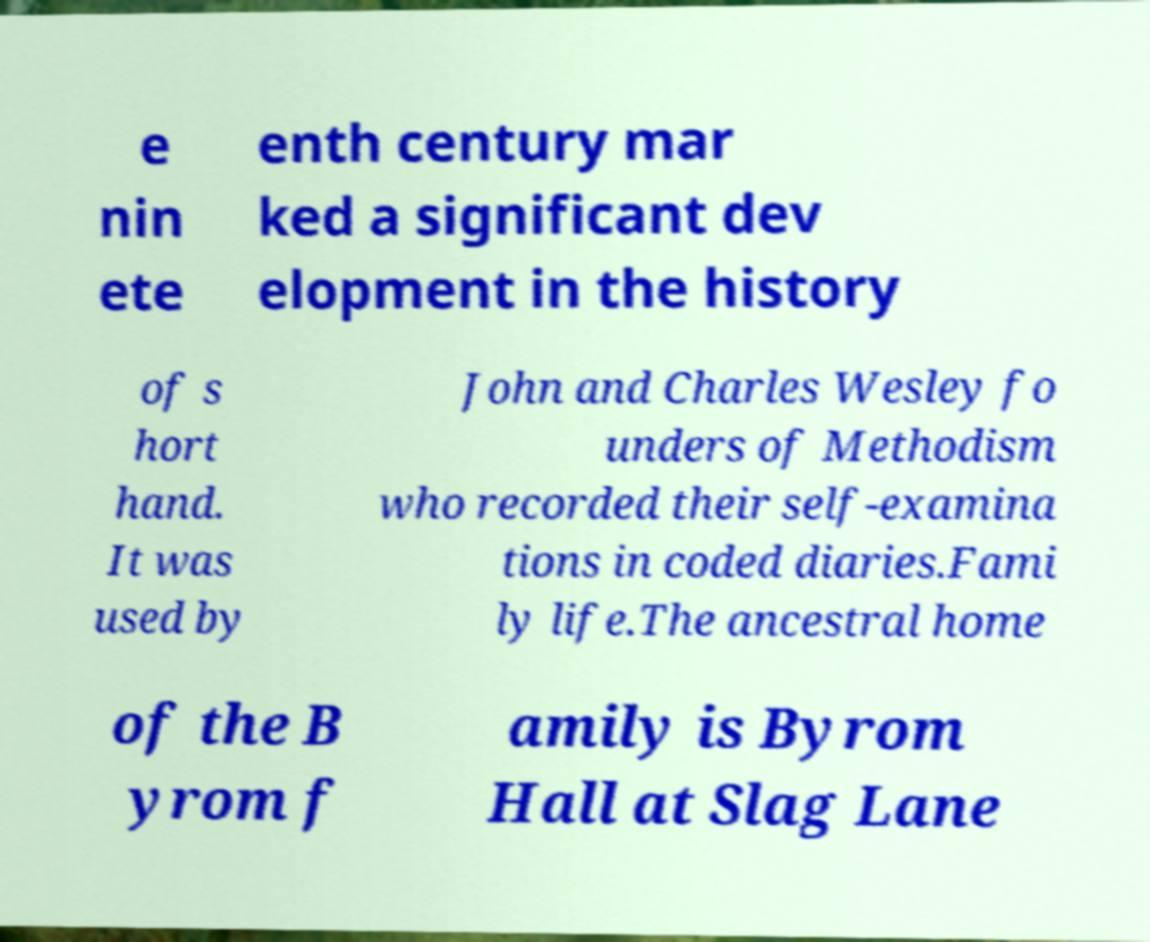Can you accurately transcribe the text from the provided image for me? e nin ete enth century mar ked a significant dev elopment in the history of s hort hand. It was used by John and Charles Wesley fo unders of Methodism who recorded their self-examina tions in coded diaries.Fami ly life.The ancestral home of the B yrom f amily is Byrom Hall at Slag Lane 